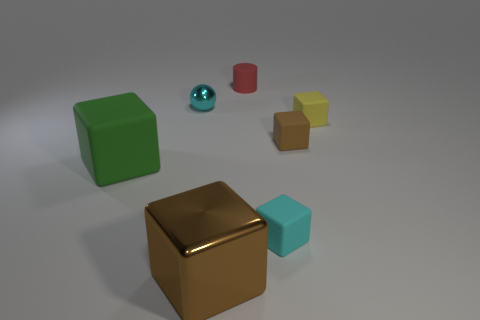Subtract all green blocks. How many blocks are left? 4 Subtract all small yellow blocks. How many blocks are left? 4 Subtract all brown spheres. Subtract all gray blocks. How many spheres are left? 1 Add 2 cyan metal things. How many objects exist? 9 Subtract all blocks. How many objects are left? 2 Add 3 purple cubes. How many purple cubes exist? 3 Subtract 0 blue cylinders. How many objects are left? 7 Subtract all tiny green matte blocks. Subtract all small objects. How many objects are left? 2 Add 7 small brown rubber cubes. How many small brown rubber cubes are left? 8 